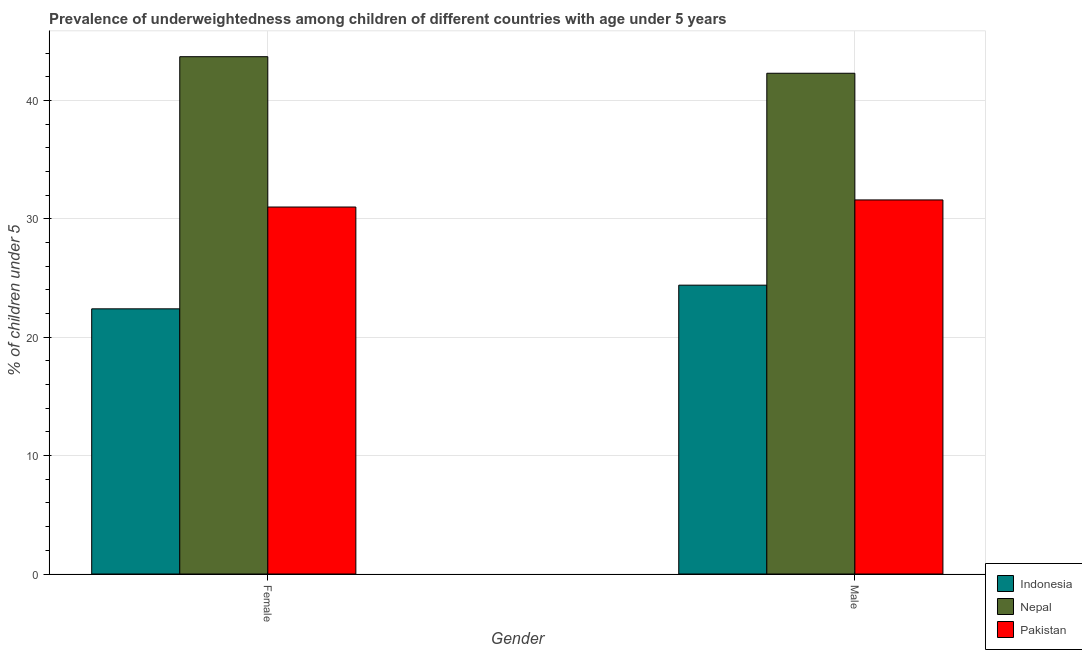Are the number of bars on each tick of the X-axis equal?
Your answer should be compact. Yes. How many bars are there on the 2nd tick from the left?
Ensure brevity in your answer.  3. How many bars are there on the 2nd tick from the right?
Give a very brief answer. 3. What is the label of the 2nd group of bars from the left?
Offer a terse response. Male. What is the percentage of underweighted male children in Pakistan?
Keep it short and to the point. 31.6. Across all countries, what is the maximum percentage of underweighted female children?
Ensure brevity in your answer.  43.7. Across all countries, what is the minimum percentage of underweighted female children?
Ensure brevity in your answer.  22.4. In which country was the percentage of underweighted female children maximum?
Your answer should be very brief. Nepal. In which country was the percentage of underweighted female children minimum?
Keep it short and to the point. Indonesia. What is the total percentage of underweighted male children in the graph?
Keep it short and to the point. 98.3. What is the difference between the percentage of underweighted female children in Pakistan and that in Indonesia?
Your response must be concise. 8.6. What is the difference between the percentage of underweighted female children in Indonesia and the percentage of underweighted male children in Nepal?
Ensure brevity in your answer.  -19.9. What is the average percentage of underweighted male children per country?
Your response must be concise. 32.77. What is the ratio of the percentage of underweighted female children in Nepal to that in Indonesia?
Provide a short and direct response. 1.95. Is the percentage of underweighted female children in Nepal less than that in Pakistan?
Give a very brief answer. No. What does the 2nd bar from the left in Male represents?
Provide a succinct answer. Nepal. What does the 1st bar from the right in Male represents?
Keep it short and to the point. Pakistan. Are all the bars in the graph horizontal?
Your answer should be compact. No. How many countries are there in the graph?
Provide a succinct answer. 3. What is the difference between two consecutive major ticks on the Y-axis?
Provide a succinct answer. 10. Are the values on the major ticks of Y-axis written in scientific E-notation?
Provide a succinct answer. No. How many legend labels are there?
Provide a succinct answer. 3. How are the legend labels stacked?
Provide a short and direct response. Vertical. What is the title of the graph?
Your answer should be compact. Prevalence of underweightedness among children of different countries with age under 5 years. Does "Virgin Islands" appear as one of the legend labels in the graph?
Offer a terse response. No. What is the label or title of the X-axis?
Provide a short and direct response. Gender. What is the label or title of the Y-axis?
Ensure brevity in your answer.   % of children under 5. What is the  % of children under 5 in Indonesia in Female?
Ensure brevity in your answer.  22.4. What is the  % of children under 5 of Nepal in Female?
Your answer should be very brief. 43.7. What is the  % of children under 5 in Pakistan in Female?
Your answer should be compact. 31. What is the  % of children under 5 in Indonesia in Male?
Your answer should be very brief. 24.4. What is the  % of children under 5 in Nepal in Male?
Your answer should be very brief. 42.3. What is the  % of children under 5 of Pakistan in Male?
Ensure brevity in your answer.  31.6. Across all Gender, what is the maximum  % of children under 5 in Indonesia?
Keep it short and to the point. 24.4. Across all Gender, what is the maximum  % of children under 5 of Nepal?
Provide a succinct answer. 43.7. Across all Gender, what is the maximum  % of children under 5 of Pakistan?
Provide a succinct answer. 31.6. Across all Gender, what is the minimum  % of children under 5 in Indonesia?
Offer a very short reply. 22.4. Across all Gender, what is the minimum  % of children under 5 in Nepal?
Offer a terse response. 42.3. What is the total  % of children under 5 of Indonesia in the graph?
Your answer should be compact. 46.8. What is the total  % of children under 5 of Pakistan in the graph?
Offer a very short reply. 62.6. What is the difference between the  % of children under 5 of Indonesia in Female and that in Male?
Ensure brevity in your answer.  -2. What is the difference between the  % of children under 5 in Indonesia in Female and the  % of children under 5 in Nepal in Male?
Offer a very short reply. -19.9. What is the average  % of children under 5 of Indonesia per Gender?
Give a very brief answer. 23.4. What is the average  % of children under 5 in Pakistan per Gender?
Offer a terse response. 31.3. What is the difference between the  % of children under 5 in Indonesia and  % of children under 5 in Nepal in Female?
Your answer should be compact. -21.3. What is the difference between the  % of children under 5 in Indonesia and  % of children under 5 in Nepal in Male?
Provide a succinct answer. -17.9. What is the difference between the  % of children under 5 of Indonesia and  % of children under 5 of Pakistan in Male?
Make the answer very short. -7.2. What is the difference between the  % of children under 5 in Nepal and  % of children under 5 in Pakistan in Male?
Keep it short and to the point. 10.7. What is the ratio of the  % of children under 5 in Indonesia in Female to that in Male?
Ensure brevity in your answer.  0.92. What is the ratio of the  % of children under 5 in Nepal in Female to that in Male?
Your answer should be very brief. 1.03. What is the ratio of the  % of children under 5 in Pakistan in Female to that in Male?
Your response must be concise. 0.98. What is the difference between the highest and the second highest  % of children under 5 in Nepal?
Offer a very short reply. 1.4. What is the difference between the highest and the second highest  % of children under 5 of Pakistan?
Provide a succinct answer. 0.6. What is the difference between the highest and the lowest  % of children under 5 of Nepal?
Your response must be concise. 1.4. 